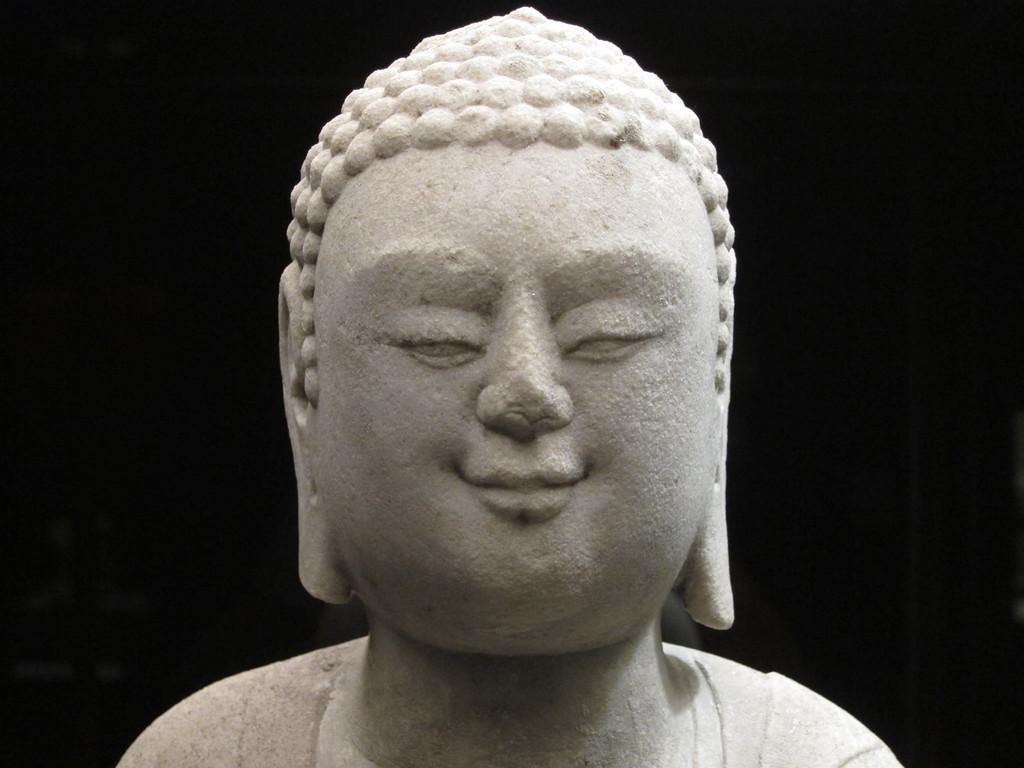What is the main subject of the image? There is an idol in the image. What can be observed about the background of the image? The background of the image is dark. Can you describe the possible setting of the image? The image may have been taken in a hall. What type of carriage is parked outside the hall in the image? There is no carriage present in the image; it only features an idol and a dark background. 